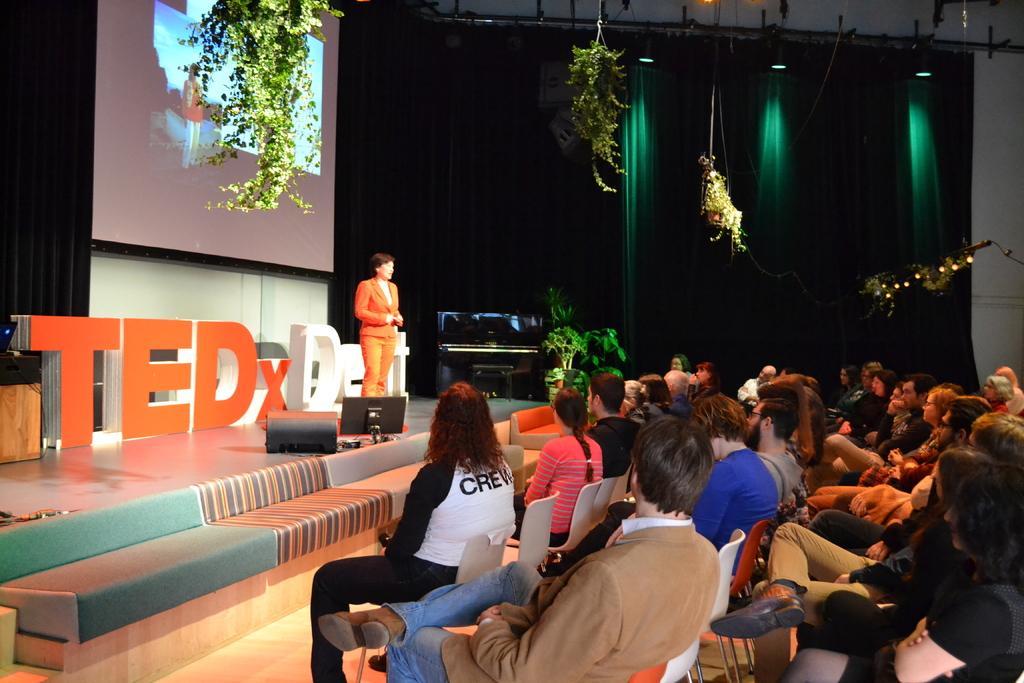In one or two sentences, can you explain what this image depicts? This is a tedx meeting. Where there is a screen on the top and plants on the top. There are lights on the top and there is a green curtain on the backside. There are so many changes and people are sitting on the chairs. And there is a person standing on the stage. There is a computer in front of her. She is wearing orange color dress. 